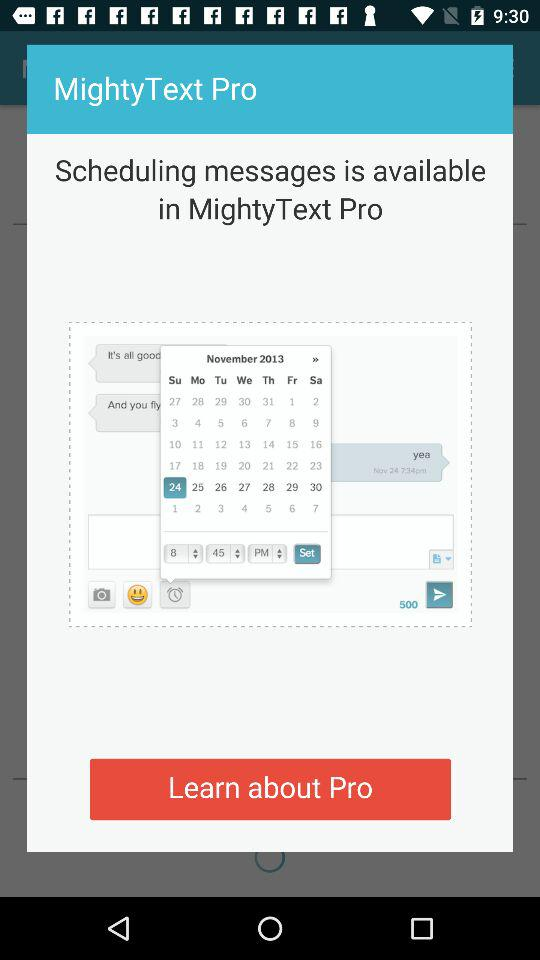What are the month and year? The month and year are November and 2013, respectively. 